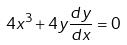Convert formula to latex. <formula><loc_0><loc_0><loc_500><loc_500>4 x ^ { 3 } + 4 y \frac { d y } { d x } = 0</formula> 